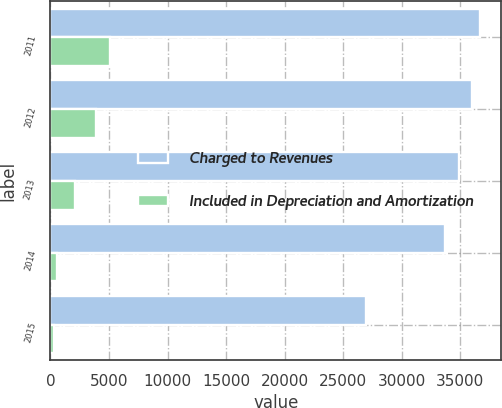<chart> <loc_0><loc_0><loc_500><loc_500><stacked_bar_chart><ecel><fcel>2011<fcel>2012<fcel>2013<fcel>2014<fcel>2015<nl><fcel>Charged to Revenues<fcel>36653<fcel>35991<fcel>34855<fcel>33729<fcel>26962<nl><fcel>Included in Depreciation and Amortization<fcel>5061<fcel>3929<fcel>2133<fcel>541<fcel>315<nl></chart> 